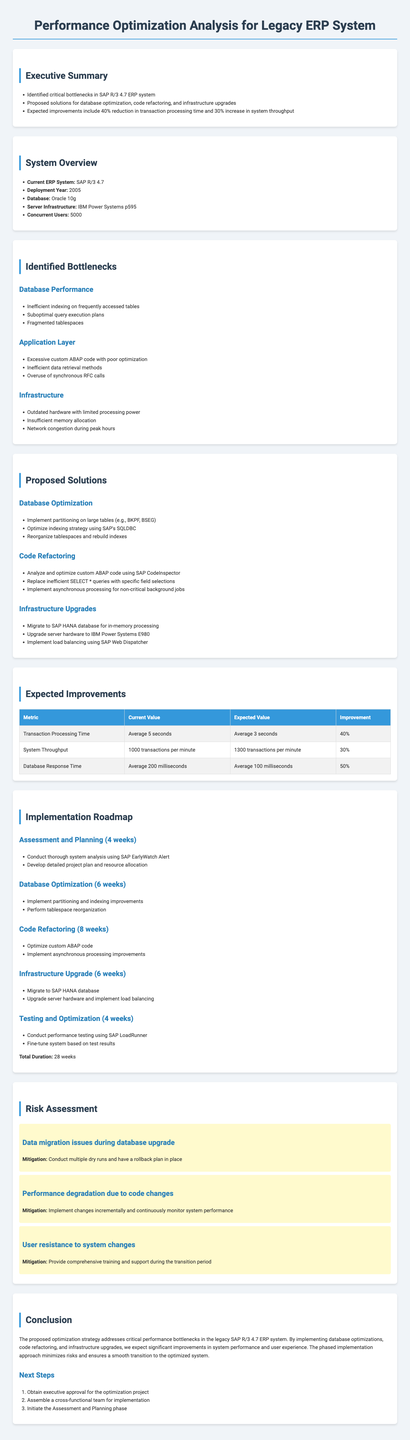What is the current ERP system? The document states the current ERP system being analyzed is SAP R/3 4.7.
Answer: SAP R/3 4.7 What is the expected percentage improvement in transaction processing time? The expected improvement in transaction processing time is listed as 40%.
Answer: 40% What area has issues with excessive custom ABAP code? The issues related to excessive custom ABAP code are identified in the Application Layer.
Answer: Application Layer What is the total duration of the implementation roadmap? The total duration for the proposed implementation roadmap is specified in the document as 28 weeks.
Answer: 28 weeks What mitigation strategy addresses user resistance to system changes? The document provides a mitigation strategy that includes providing comprehensive training and support to address user resistance.
Answer: Comprehensive training and support What is the current value of database response time? The document states that the current value for database response time is 200 milliseconds.
Answer: 200 milliseconds What category of proposed solutions includes migrating to SAP HANA? The proposed solution category that includes migrating to SAP HANA is Infrastructure Upgrades.
Answer: Infrastructure Upgrades How many concurrent users does the current ERP system support? The document indicates that the current ERP system supports 5000 concurrent users.
Answer: 5000 